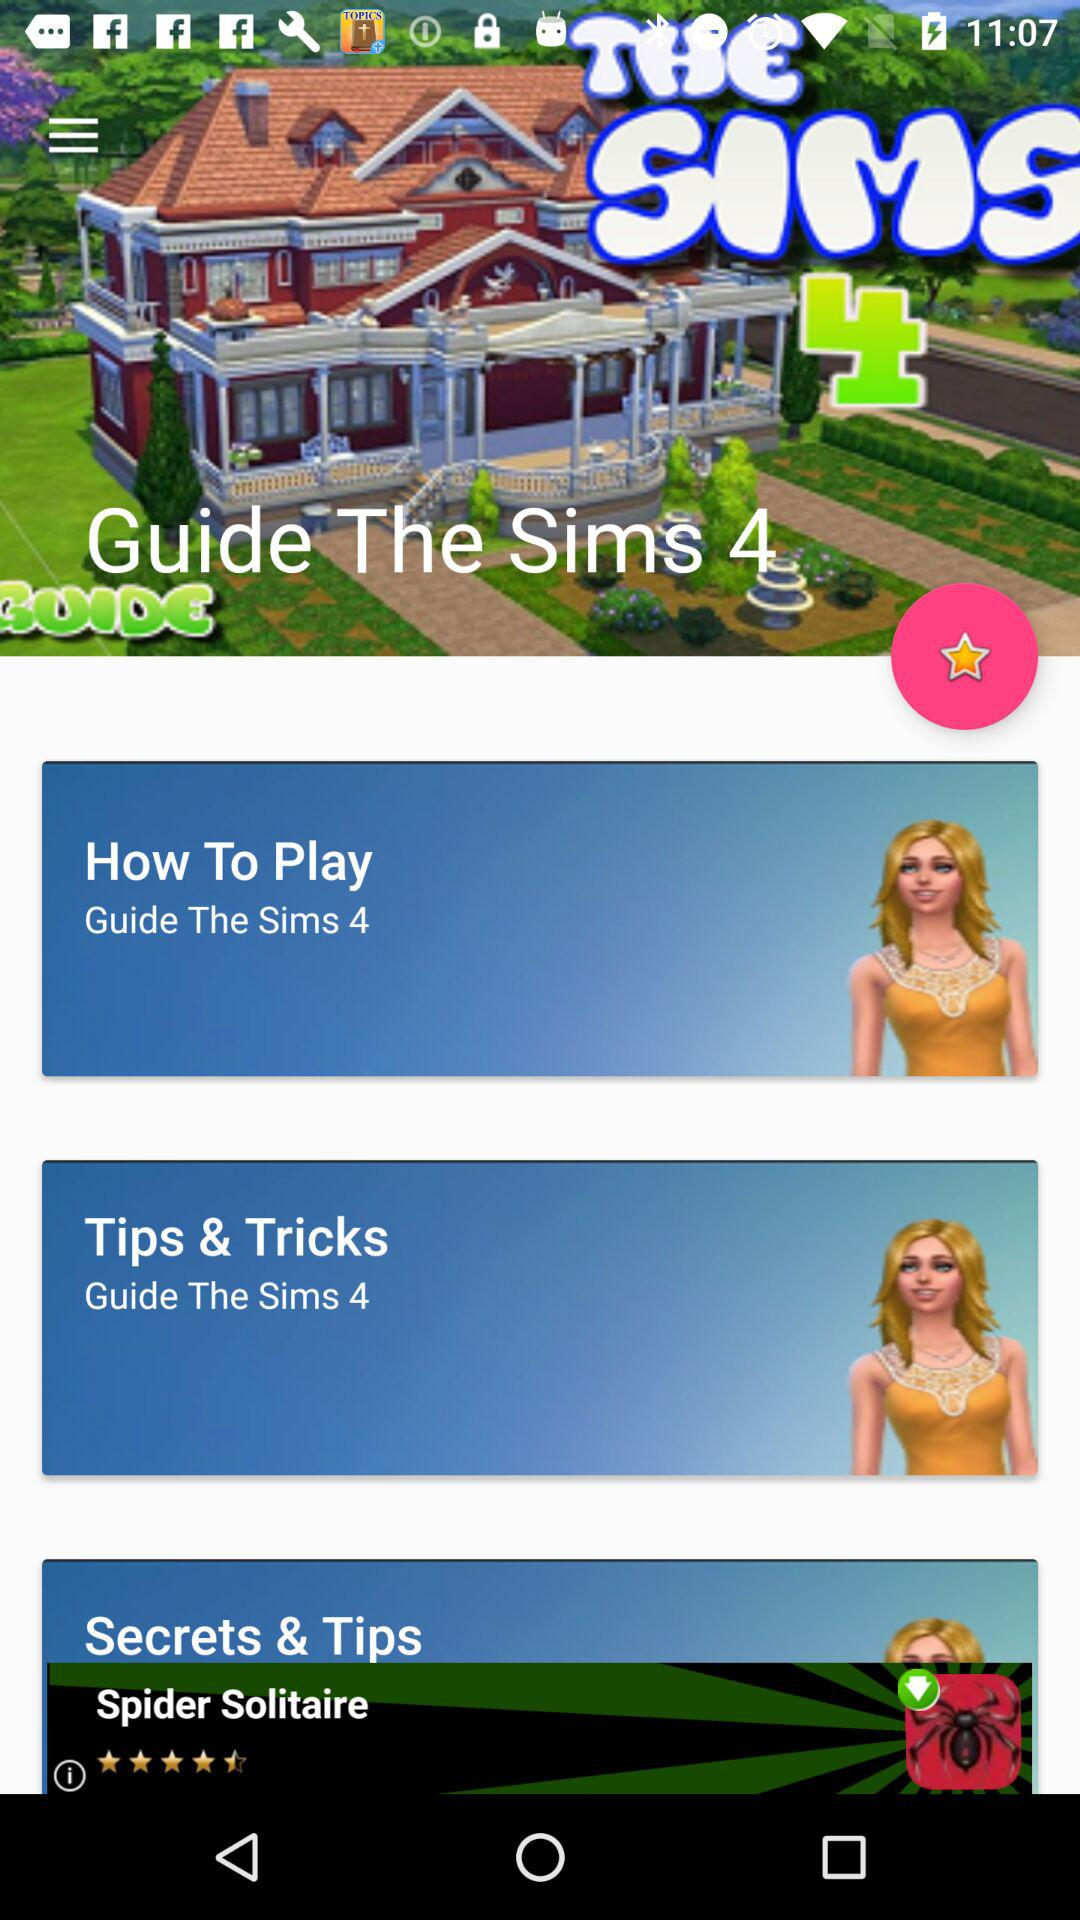What is the application name? The application name is "Guide The Sims 4". 